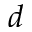<formula> <loc_0><loc_0><loc_500><loc_500>d</formula> 